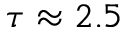<formula> <loc_0><loc_0><loc_500><loc_500>\tau \approx 2 . 5</formula> 